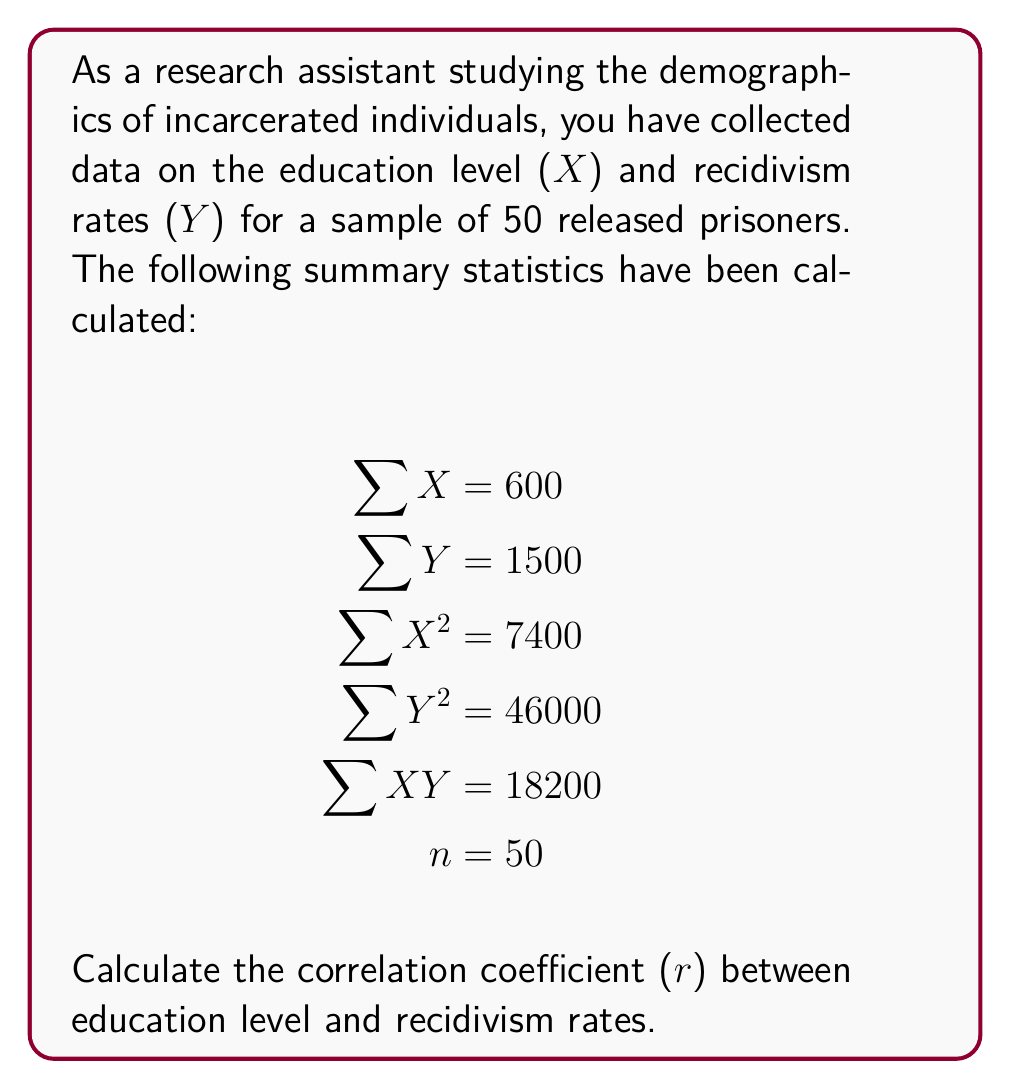Could you help me with this problem? To calculate the correlation coefficient (r), we'll use the formula:

$$ r = \frac{n\sum XY - (\sum X)(\sum Y)}{\sqrt{[n\sum X^2 - (\sum X)^2][n\sum Y^2 - (\sum Y)^2]}} $$

Let's substitute the given values:

$$ r = \frac{50(18200) - (600)(1500)}{\sqrt{[50(7400) - (600)^2][50(46000) - (1500)^2]}} $$

Now, let's solve step by step:

1. Calculate the numerator:
   $50(18200) - (600)(1500) = 910000 - 900000 = 10000$

2. Calculate the parts under the square root in the denominator:
   $50(7400) - (600)^2 = 370000 - 360000 = 10000$
   $50(46000) - (1500)^2 = 2300000 - 2250000 = 50000$

3. Multiply these parts:
   $10000 * 50000 = 500000000$

4. Take the square root:
   $\sqrt{500000000} = 22360.68$

5. Divide the numerator by the denominator:
   $r = \frac{10000}{22360.68} = 0.4472$

The correlation coefficient is approximately 0.4472.
Answer: $r \approx 0.4472$ 